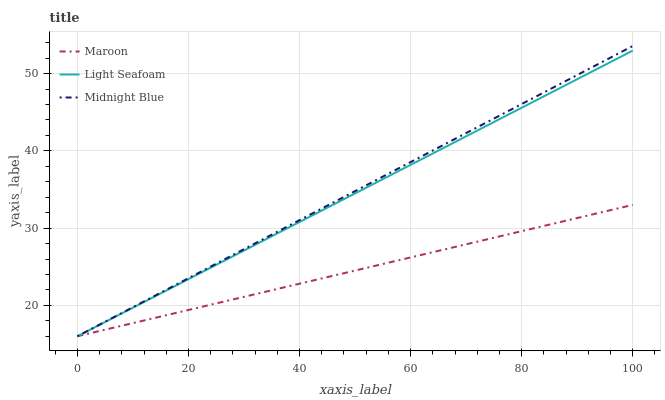Does Maroon have the minimum area under the curve?
Answer yes or no. Yes. Does Midnight Blue have the maximum area under the curve?
Answer yes or no. Yes. Does Midnight Blue have the minimum area under the curve?
Answer yes or no. No. Does Maroon have the maximum area under the curve?
Answer yes or no. No. Is Maroon the smoothest?
Answer yes or no. Yes. Is Light Seafoam the roughest?
Answer yes or no. Yes. Is Midnight Blue the smoothest?
Answer yes or no. No. Is Midnight Blue the roughest?
Answer yes or no. No. Does Midnight Blue have the highest value?
Answer yes or no. Yes. Does Maroon have the highest value?
Answer yes or no. No. 